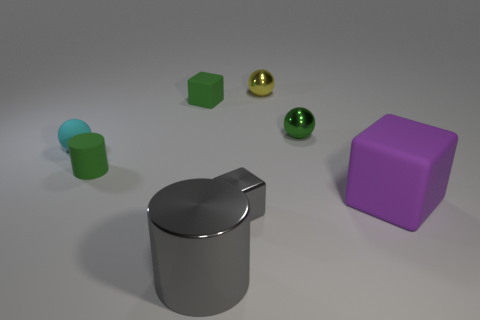The metal thing that is the same color as the small metal cube is what size?
Keep it short and to the point. Large. What color is the small thing that is to the left of the tiny green rubber thing in front of the tiny cube that is left of the tiny shiny block?
Make the answer very short. Cyan. Are the big gray cylinder and the cube that is to the right of the yellow thing made of the same material?
Provide a succinct answer. No. What is the big gray thing made of?
Give a very brief answer. Metal. There is a block that is the same color as the tiny rubber cylinder; what is its material?
Keep it short and to the point. Rubber. What is the shape of the small metallic object that is behind the purple matte cube and in front of the yellow sphere?
Your answer should be very brief. Sphere. The small sphere that is made of the same material as the purple cube is what color?
Ensure brevity in your answer.  Cyan. Are there an equal number of tiny green metallic spheres on the left side of the cyan matte thing and tiny brown cubes?
Provide a short and direct response. Yes. There is a cyan object that is the same size as the green matte cylinder; what shape is it?
Offer a terse response. Sphere. What number of other things are there of the same shape as the small cyan thing?
Keep it short and to the point. 2. 